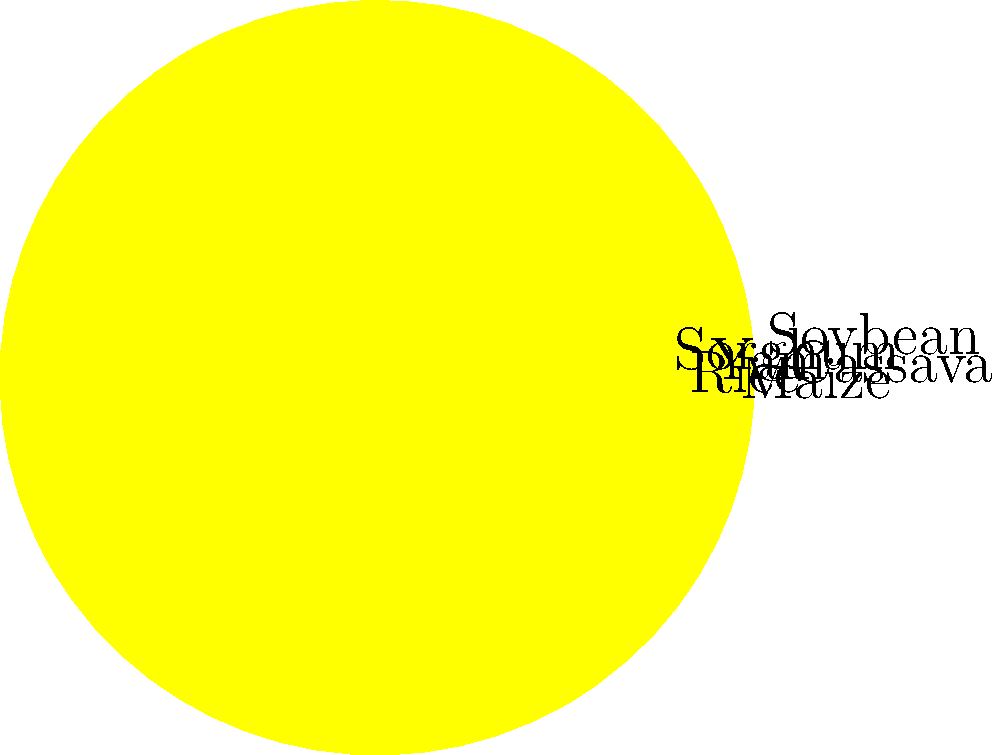In the polar area chart representing crop yields for various crops in Nigeria, which crop shows the highest yield per hectare? To determine the crop with the highest yield per hectare, we need to analyze the polar area chart:

1. The chart represents six crops: Maize, Rice, Cassava, Yam, Sorghum, and Soybean.
2. Each crop is represented by a colored sector in the circular chart.
3. The area of each sector is proportional to the crop's yield.
4. The larger the sector, the higher the yield.
5. By visually comparing the sectors, we can see that the largest sector corresponds to Cassava.
6. The Cassava sector extends furthest from the center of the circle, indicating it has the highest yield among all crops shown.

Therefore, based on the information provided in the polar area chart, Cassava has the highest yield per hectare among the crops represented.
Answer: Cassava 